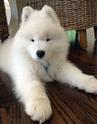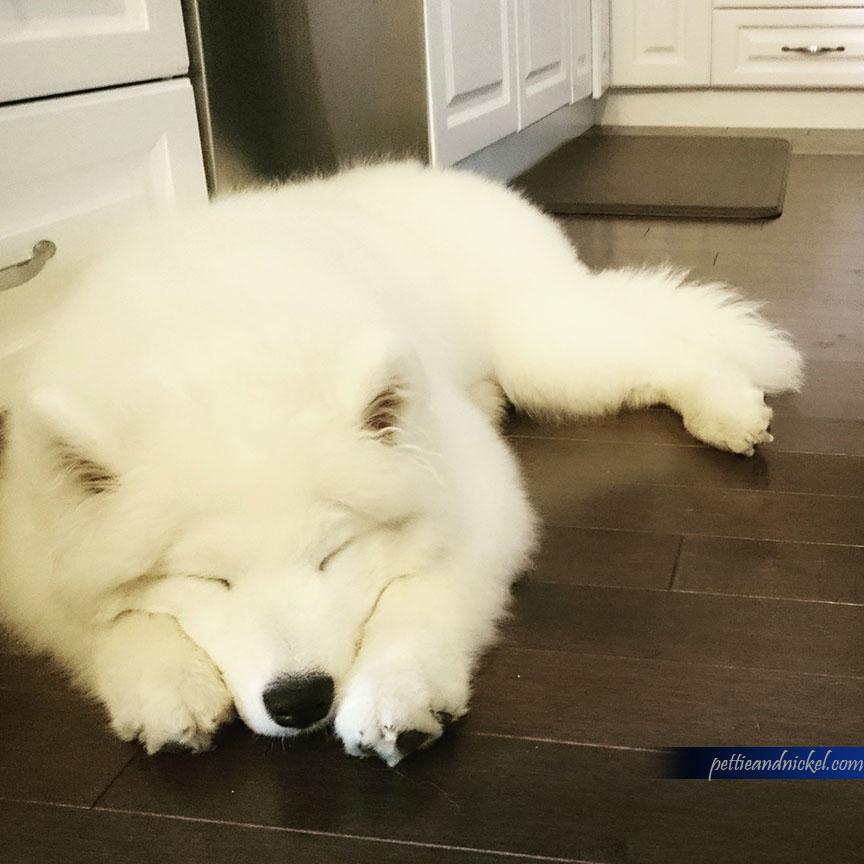The first image is the image on the left, the second image is the image on the right. For the images displayed, is the sentence "The dog in the image on the right is on a wooden floor." factually correct? Answer yes or no. Yes. The first image is the image on the left, the second image is the image on the right. Assess this claim about the two images: "Each image contains exactly one reclining white dog.". Correct or not? Answer yes or no. Yes. 